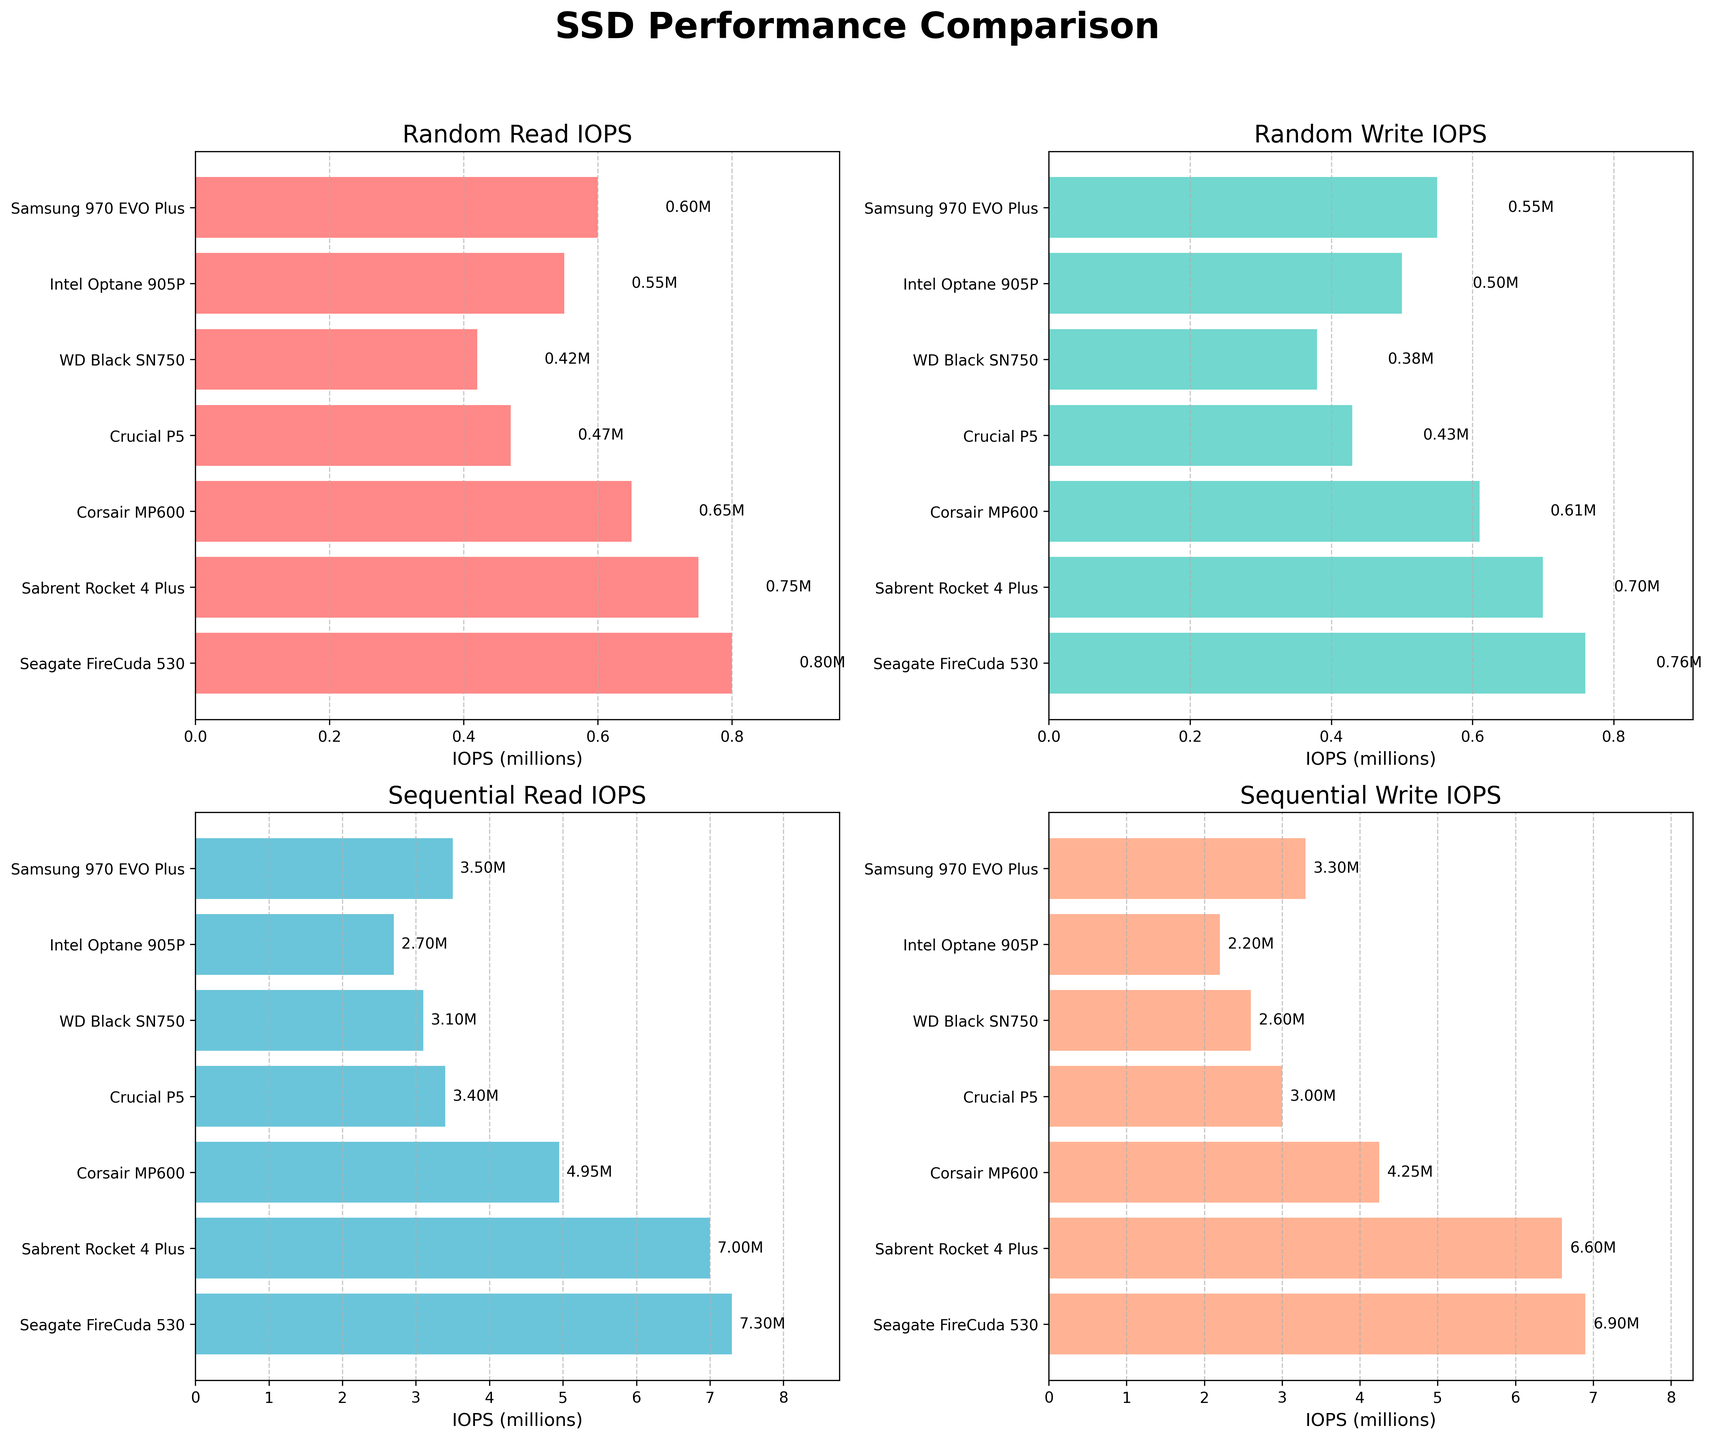What does the title of the figure indicate? The title of the figure is "SSD Performance Comparison," which tells us that the figure compares the performance of various SSDs in different IOPS metrics.
Answer: SSD Performance Comparison Which SSD has the highest Random_Read_IOPS? In the subplot titled "Random Read IOPS," the bar for "Seagate FireCuda 530" is the tallest, indicating it has the highest value.
Answer: Seagate FireCuda 530 How many different SSD types are compared in the figure? All subplots have seven SSDs listed on the y-axis. Therefore, the figure compares seven different SSD types.
Answer: 7 What is the IOPS value for the "WD Black SN750" in the Sequential_Read_IOPS subplot? In the "Sequential Read IOPS" subplot, the bar for "WD Black SN750" reaches approximately 3100000 IOPS.
Answer: 3100000 Which SSD has the lowest Random_Write_IOPS, and what is its value? In the "Random Write IOPS" subplot, the shortest bar corresponds to the "WD Black SN750," with a value of approximately 380000 IOPS.
Answer: WD Black SN750, 380000 Which SSD shows the smallest gap between Sequential_Read_IOPS and Sequential_Write_IOPS? The "Intel Optane 905P" has Sequential Read (2700000) and Sequential Write (2200000) values, resulting in a difference of 500000 IOPS. This is the smallest gap observed in the subplots.
Answer: Intel Optane 905P If we sum the Sequential_Write_IOPS for all SSDs, what is the total value? Sum the values: 3300000 (Samsung 970 EVO Plus) + 2200000 (Intel Optane 905P) + 2600000 (WD Black SN750) + 3000000 (Crucial P5) + 4250000 (Corsair MP600) + 6600000 (Sabrent Rocket 4 Plus) + 6900000 (Seagate FireCuda 530). The total is 28850000 IOPS.
Answer: 28850000 In the Sequential_Read_IOPS subplot, which SSDs have an IOPS value greater than 3500000? In the "Sequential Read IOPS" subplot, "Samsung 970 EVO Plus," "Crucial P5," "Corsair MP600," "Sabrent Rocket 4 Plus," and "Seagate FireCuda 530" have bars extending above 3500000 IOPS.
Answer: Samsung 970 EVO Plus, Crucial P5, Corsair MP600, Sabrent Rocket 4 Plus, Seagate FireCuda 530 What is the average Random_Write_IOPS across all SSDs? The values are 550000 (Samsung 970 EVO Plus), 500000 (Intel Optane 905P), 380000 (WD Black SN750), 430000 (Crucial P5), 610000 (Corsair MP600), 700000 (Sabrent Rocket 4 Plus), 760000 (Seagate FireCuda 530). The sum is 3930000, and the average is 3930000 / 7 ≈ 561428.57 IOPS.
Answer: 561428.57 